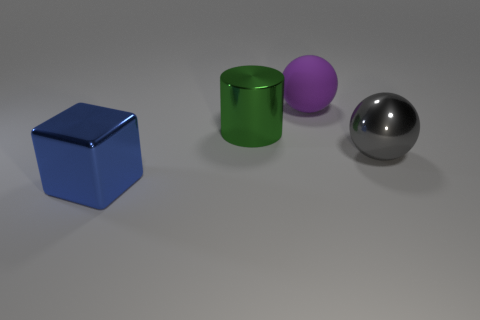There is a purple rubber thing; is it the same shape as the thing on the left side of the cylinder?
Ensure brevity in your answer.  No. What number of big things are both in front of the purple object and behind the metallic block?
Provide a succinct answer. 2. What is the material of the other thing that is the same shape as the big purple rubber object?
Provide a succinct answer. Metal. There is a metallic object to the right of the sphere behind the big gray object; what is its size?
Offer a terse response. Large. Is there a large thing?
Keep it short and to the point. Yes. There is a object that is both behind the big blue thing and left of the big purple object; what is its material?
Provide a short and direct response. Metal. Is the number of big balls that are left of the large green shiny cylinder greater than the number of metal things in front of the metallic cube?
Give a very brief answer. No. Are there any green things of the same size as the purple rubber thing?
Your answer should be very brief. Yes. There is a ball in front of the ball to the left of the sphere that is in front of the big green cylinder; how big is it?
Keep it short and to the point. Large. The large rubber ball is what color?
Ensure brevity in your answer.  Purple. 